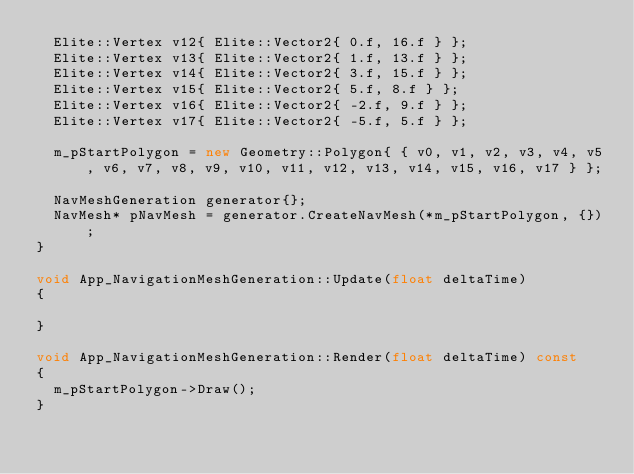Convert code to text. <code><loc_0><loc_0><loc_500><loc_500><_C++_>	Elite::Vertex v12{ Elite::Vector2{ 0.f, 16.f } };
	Elite::Vertex v13{ Elite::Vector2{ 1.f, 13.f } };
	Elite::Vertex v14{ Elite::Vector2{ 3.f, 15.f } };
	Elite::Vertex v15{ Elite::Vector2{ 5.f, 8.f } };
	Elite::Vertex v16{ Elite::Vector2{ -2.f, 9.f } };
	Elite::Vertex v17{ Elite::Vector2{ -5.f, 5.f } };

	m_pStartPolygon = new Geometry::Polygon{ { v0, v1, v2, v3, v4, v5, v6, v7, v8, v9, v10, v11, v12, v13, v14, v15, v16, v17 } };

	NavMeshGeneration generator{};
	NavMesh* pNavMesh = generator.CreateNavMesh(*m_pStartPolygon, {});
}

void App_NavigationMeshGeneration::Update(float deltaTime)
{

}

void App_NavigationMeshGeneration::Render(float deltaTime) const
{
	m_pStartPolygon->Draw();
}</code> 